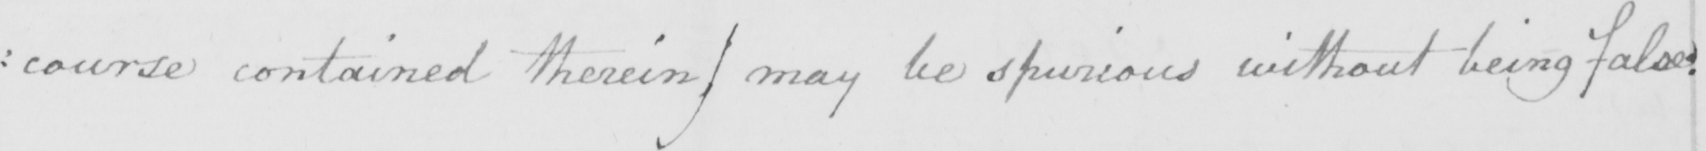Please provide the text content of this handwritten line. : course contained therein )  may be spurious without being false : 